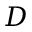<formula> <loc_0><loc_0><loc_500><loc_500>D</formula> 